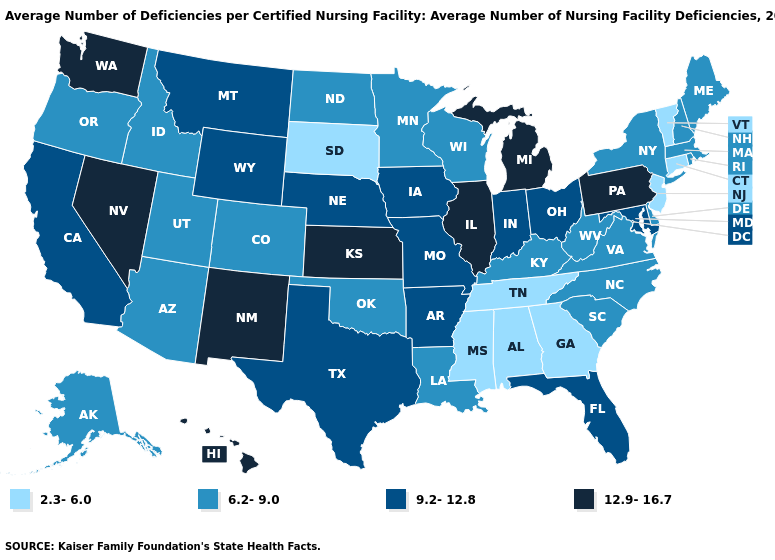Name the states that have a value in the range 9.2-12.8?
Be succinct. Arkansas, California, Florida, Indiana, Iowa, Maryland, Missouri, Montana, Nebraska, Ohio, Texas, Wyoming. Does West Virginia have a lower value than Vermont?
Write a very short answer. No. Name the states that have a value in the range 9.2-12.8?
Answer briefly. Arkansas, California, Florida, Indiana, Iowa, Maryland, Missouri, Montana, Nebraska, Ohio, Texas, Wyoming. What is the highest value in the MidWest ?
Give a very brief answer. 12.9-16.7. Name the states that have a value in the range 9.2-12.8?
Be succinct. Arkansas, California, Florida, Indiana, Iowa, Maryland, Missouri, Montana, Nebraska, Ohio, Texas, Wyoming. Name the states that have a value in the range 6.2-9.0?
Quick response, please. Alaska, Arizona, Colorado, Delaware, Idaho, Kentucky, Louisiana, Maine, Massachusetts, Minnesota, New Hampshire, New York, North Carolina, North Dakota, Oklahoma, Oregon, Rhode Island, South Carolina, Utah, Virginia, West Virginia, Wisconsin. What is the highest value in states that border Indiana?
Concise answer only. 12.9-16.7. What is the value of Texas?
Short answer required. 9.2-12.8. Does South Carolina have the highest value in the South?
Be succinct. No. Name the states that have a value in the range 9.2-12.8?
Be succinct. Arkansas, California, Florida, Indiana, Iowa, Maryland, Missouri, Montana, Nebraska, Ohio, Texas, Wyoming. Does the first symbol in the legend represent the smallest category?
Concise answer only. Yes. What is the value of Vermont?
Keep it brief. 2.3-6.0. What is the value of Colorado?
Answer briefly. 6.2-9.0. Name the states that have a value in the range 12.9-16.7?
Write a very short answer. Hawaii, Illinois, Kansas, Michigan, Nevada, New Mexico, Pennsylvania, Washington. What is the lowest value in states that border Arkansas?
Write a very short answer. 2.3-6.0. 